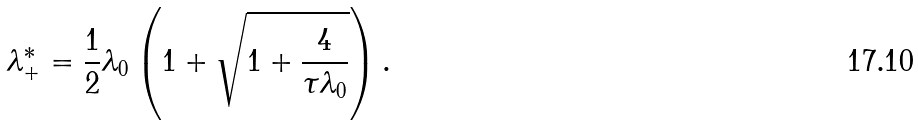Convert formula to latex. <formula><loc_0><loc_0><loc_500><loc_500>\lambda ^ { * } _ { + } = \frac { 1 } { 2 } \lambda _ { 0 } \left ( 1 + \sqrt { 1 + \frac { 4 } { \tau \lambda _ { 0 } } } \right ) .</formula> 